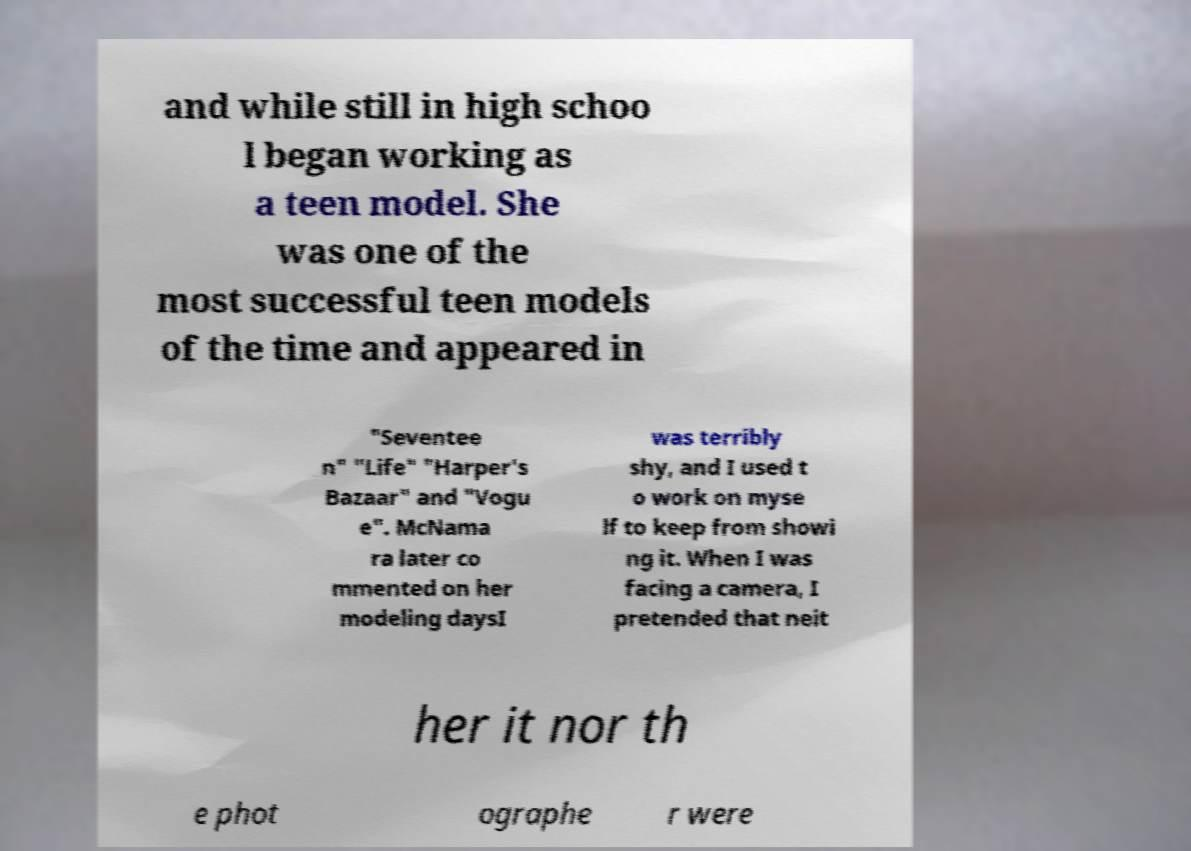What messages or text are displayed in this image? I need them in a readable, typed format. and while still in high schoo l began working as a teen model. She was one of the most successful teen models of the time and appeared in "Seventee n" "Life" "Harper's Bazaar" and "Vogu e". McNama ra later co mmented on her modeling daysI was terribly shy, and I used t o work on myse lf to keep from showi ng it. When I was facing a camera, I pretended that neit her it nor th e phot ographe r were 